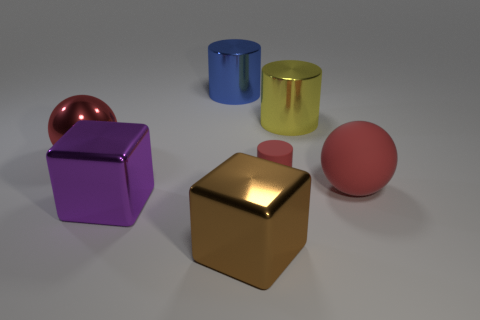Is there any other thing that has the same size as the rubber cylinder?
Keep it short and to the point. No. There is a matte sphere that is the same color as the small cylinder; what size is it?
Your response must be concise. Large. There is a rubber thing that is the same color as the matte cylinder; what shape is it?
Provide a short and direct response. Sphere. What size is the red rubber cylinder that is behind the purple metal object?
Your response must be concise. Small. There is a large ball behind the matte object that is to the right of the large yellow cylinder; what number of red rubber balls are behind it?
Give a very brief answer. 0. There is a large cylinder that is to the right of the big brown thing to the right of the blue thing; what is its color?
Provide a short and direct response. Yellow. Is there another red ball of the same size as the red shiny sphere?
Give a very brief answer. Yes. The block right of the metallic object behind the metal cylinder that is to the right of the red rubber cylinder is made of what material?
Your response must be concise. Metal. There is a big red sphere that is left of the large blue shiny cylinder; how many red rubber balls are to the right of it?
Keep it short and to the point. 1. Does the purple block that is in front of the blue metallic cylinder have the same size as the blue shiny object?
Make the answer very short. Yes. 